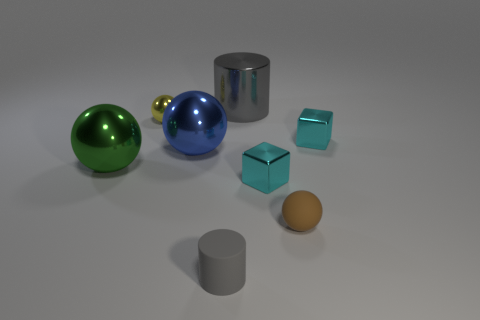Add 2 purple balls. How many objects exist? 10 Subtract all blocks. How many objects are left? 6 Subtract all large blue cylinders. Subtract all metallic cylinders. How many objects are left? 7 Add 8 blue shiny spheres. How many blue shiny spheres are left? 9 Add 2 small balls. How many small balls exist? 4 Subtract 0 cyan spheres. How many objects are left? 8 